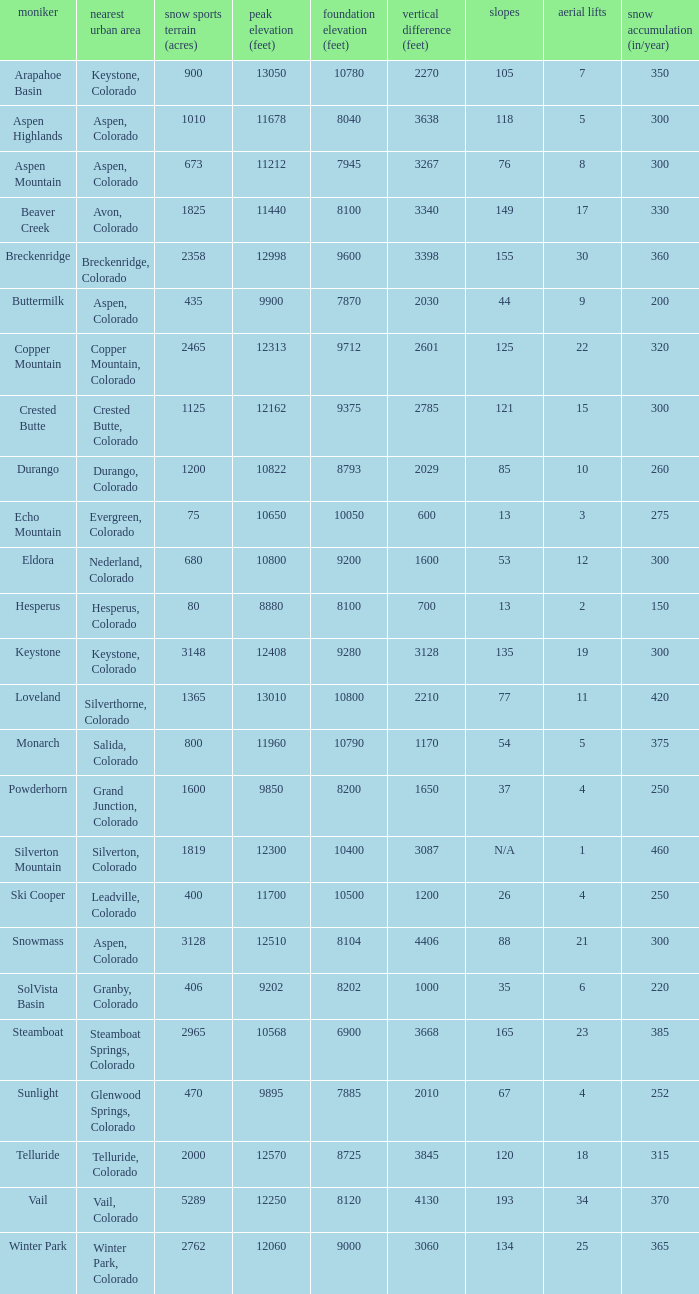If there are 30 lifts, what is the name of the ski resort? Breckenridge. 